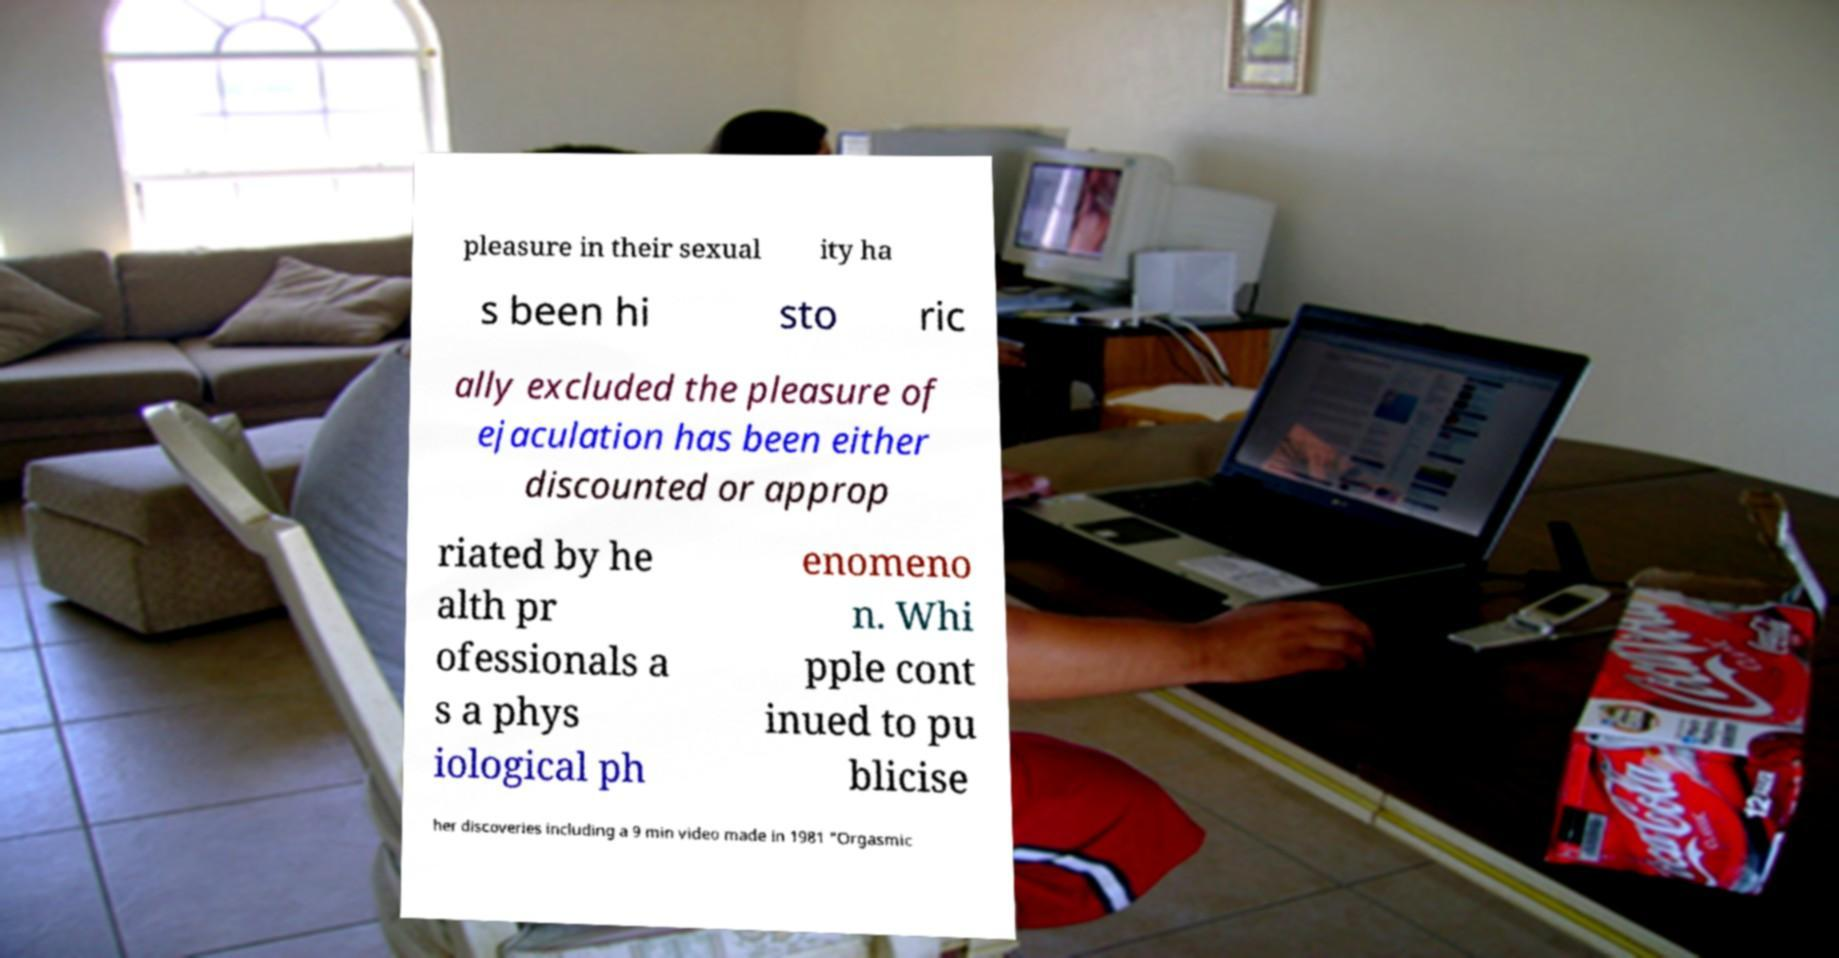For documentation purposes, I need the text within this image transcribed. Could you provide that? pleasure in their sexual ity ha s been hi sto ric ally excluded the pleasure of ejaculation has been either discounted or approp riated by he alth pr ofessionals a s a phys iological ph enomeno n. Whi pple cont inued to pu blicise her discoveries including a 9 min video made in 1981 "Orgasmic 